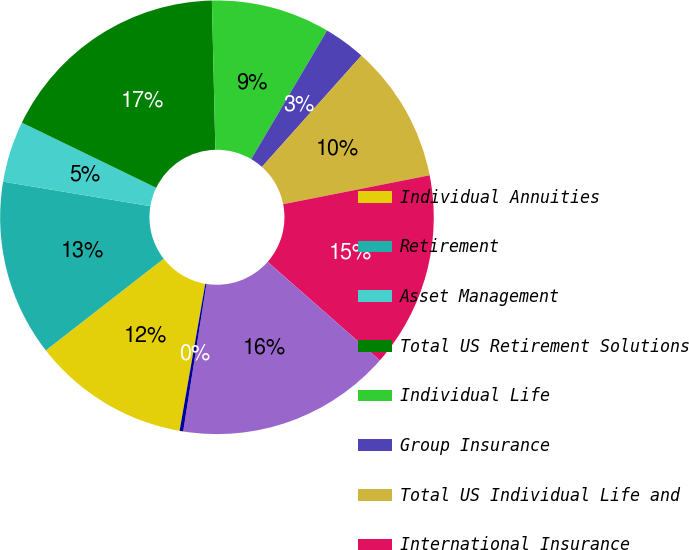Convert chart. <chart><loc_0><loc_0><loc_500><loc_500><pie_chart><fcel>Individual Annuities<fcel>Retirement<fcel>Asset Management<fcel>Total US Retirement Solutions<fcel>Individual Life<fcel>Group Insurance<fcel>Total US Individual Life and<fcel>International Insurance<fcel>Total International Insurance<fcel>Corporate and Other operations<nl><fcel>11.72%<fcel>13.15%<fcel>4.56%<fcel>17.44%<fcel>8.85%<fcel>3.13%<fcel>10.29%<fcel>14.58%<fcel>16.01%<fcel>0.27%<nl></chart> 